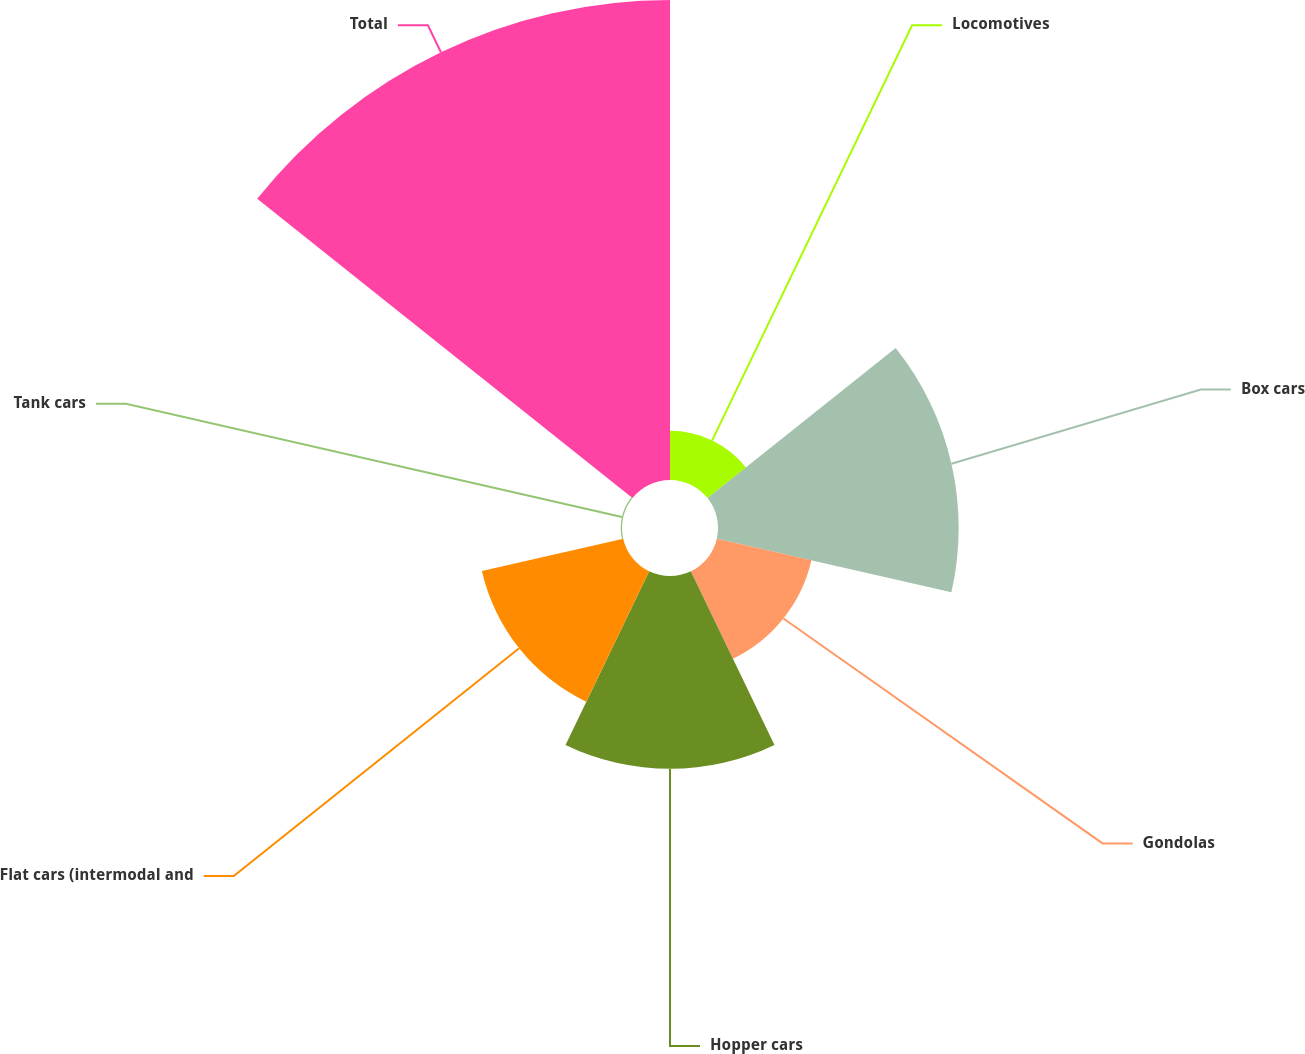Convert chart. <chart><loc_0><loc_0><loc_500><loc_500><pie_chart><fcel>Locomotives<fcel>Box cars<fcel>Gondolas<fcel>Hopper cars<fcel>Flat cars (intermodal and<fcel>Tank cars<fcel>Total<nl><fcel>4.08%<fcel>19.96%<fcel>8.05%<fcel>15.99%<fcel>12.02%<fcel>0.11%<fcel>39.81%<nl></chart> 